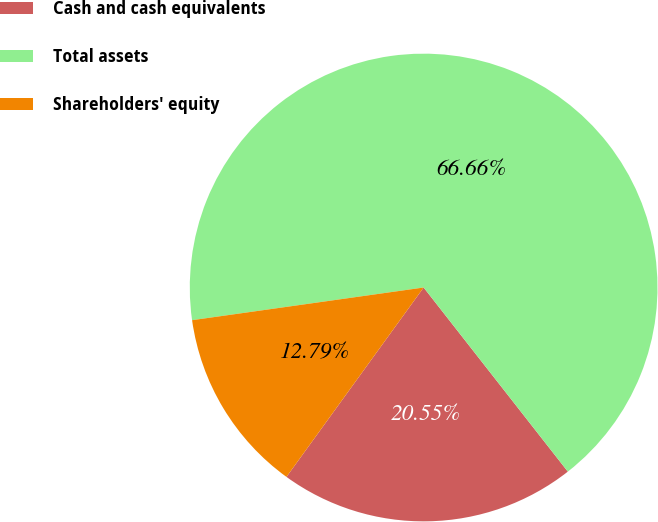Convert chart. <chart><loc_0><loc_0><loc_500><loc_500><pie_chart><fcel>Cash and cash equivalents<fcel>Total assets<fcel>Shareholders' equity<nl><fcel>20.55%<fcel>66.65%<fcel>12.79%<nl></chart> 